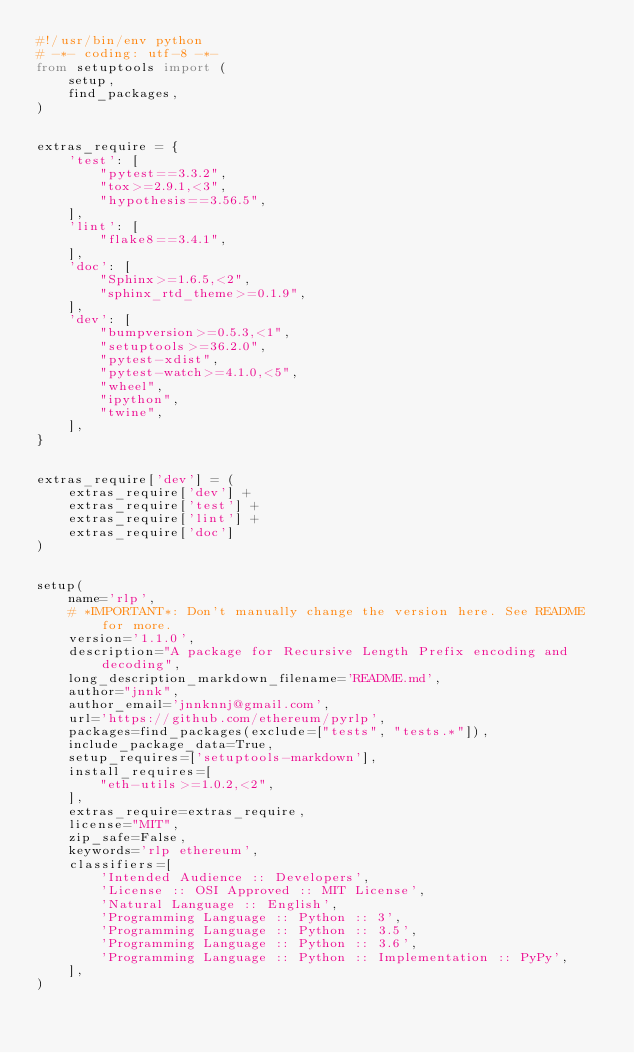Convert code to text. <code><loc_0><loc_0><loc_500><loc_500><_Python_>#!/usr/bin/env python
# -*- coding: utf-8 -*-
from setuptools import (
    setup,
    find_packages,
)


extras_require = {
    'test': [
        "pytest==3.3.2",
        "tox>=2.9.1,<3",
        "hypothesis==3.56.5",
    ],
    'lint': [
        "flake8==3.4.1",
    ],
    'doc': [
        "Sphinx>=1.6.5,<2",
        "sphinx_rtd_theme>=0.1.9",
    ],
    'dev': [
        "bumpversion>=0.5.3,<1",
        "setuptools>=36.2.0",
        "pytest-xdist",
        "pytest-watch>=4.1.0,<5",
        "wheel",
        "ipython",
        "twine",
    ],
}


extras_require['dev'] = (
    extras_require['dev'] +
    extras_require['test'] +
    extras_require['lint'] +
    extras_require['doc']
)


setup(
    name='rlp',
    # *IMPORTANT*: Don't manually change the version here. See README for more.
    version='1.1.0',
    description="A package for Recursive Length Prefix encoding and decoding",
    long_description_markdown_filename='README.md',
    author="jnnk",
    author_email='jnnknnj@gmail.com',
    url='https://github.com/ethereum/pyrlp',
    packages=find_packages(exclude=["tests", "tests.*"]),
    include_package_data=True,
    setup_requires=['setuptools-markdown'],
    install_requires=[
        "eth-utils>=1.0.2,<2",
    ],
    extras_require=extras_require,
    license="MIT",
    zip_safe=False,
    keywords='rlp ethereum',
    classifiers=[
        'Intended Audience :: Developers',
        'License :: OSI Approved :: MIT License',
        'Natural Language :: English',
        'Programming Language :: Python :: 3',
        'Programming Language :: Python :: 3.5',
        'Programming Language :: Python :: 3.6',
        'Programming Language :: Python :: Implementation :: PyPy',
    ],
)
</code> 